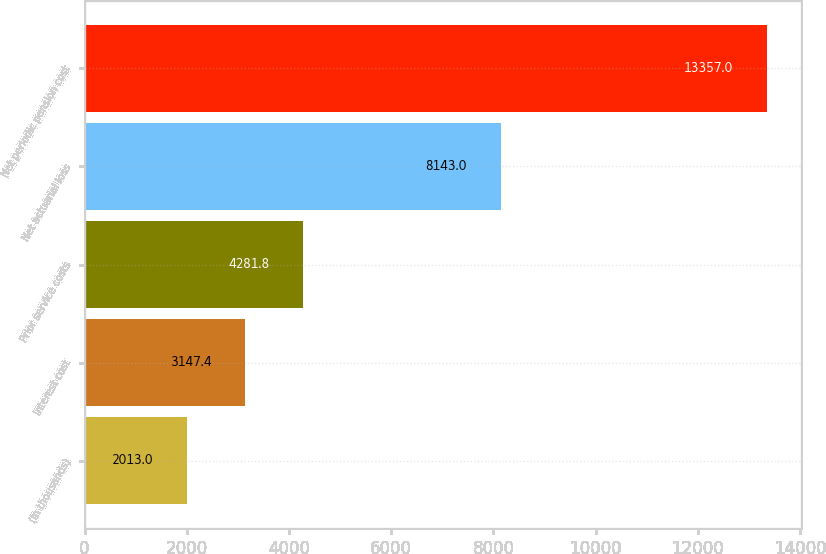Convert chart to OTSL. <chart><loc_0><loc_0><loc_500><loc_500><bar_chart><fcel>(In thousands)<fcel>Interest cost<fcel>Prior service costs<fcel>Net actuarial loss<fcel>Net periodic pension cost<nl><fcel>2013<fcel>3147.4<fcel>4281.8<fcel>8143<fcel>13357<nl></chart> 